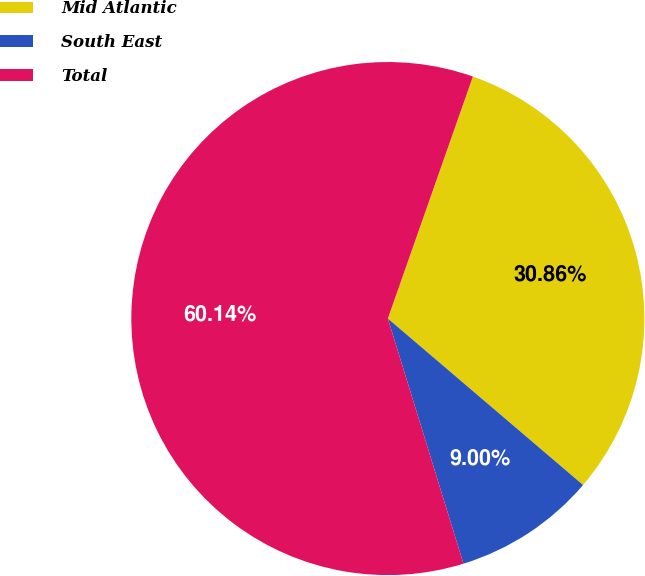<chart> <loc_0><loc_0><loc_500><loc_500><pie_chart><fcel>Mid Atlantic<fcel>South East<fcel>Total<nl><fcel>30.86%<fcel>9.0%<fcel>60.14%<nl></chart> 